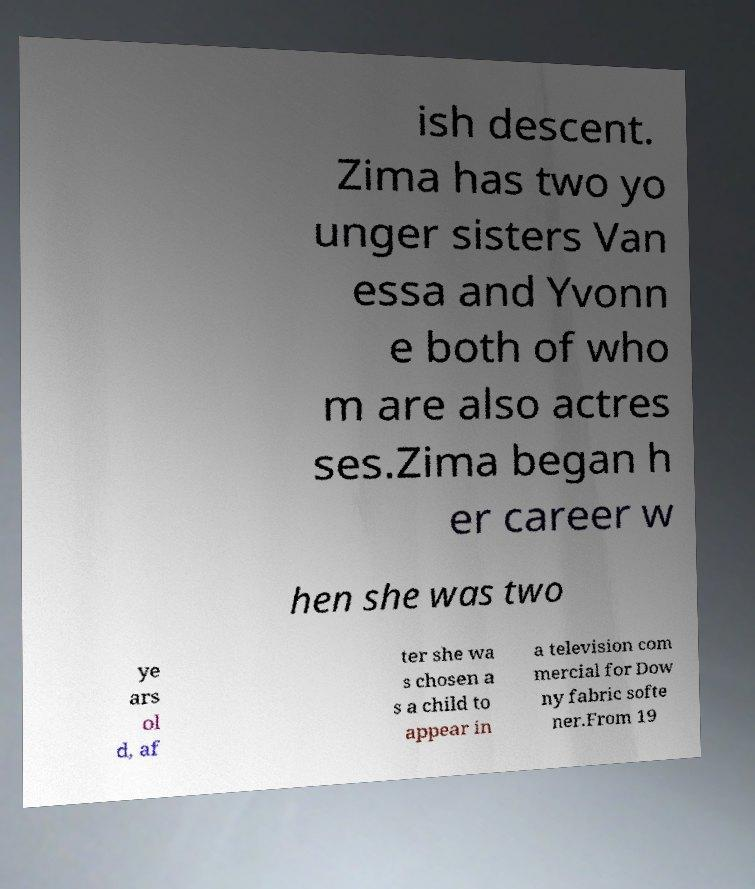Please identify and transcribe the text found in this image. ish descent. Zima has two yo unger sisters Van essa and Yvonn e both of who m are also actres ses.Zima began h er career w hen she was two ye ars ol d, af ter she wa s chosen a s a child to appear in a television com mercial for Dow ny fabric softe ner.From 19 